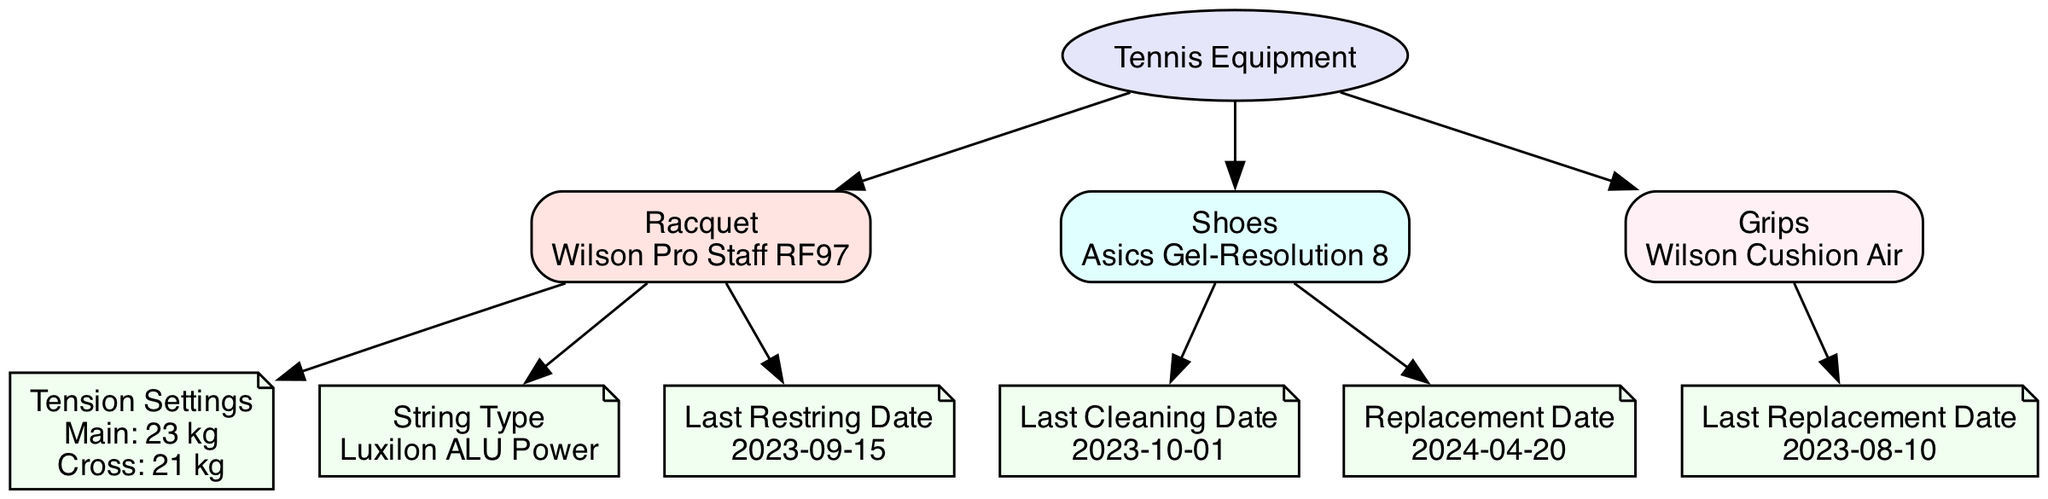What is the string type used for the racquet? To find the string type, locate the "Racquet" node, then look at the outgoing edge leading to the "String Type" node, which contains the value.
Answer: Luxilon ALU Power What is the last cleaning date for the shoes? To get the last cleaning date, find the "Shoes" node, then follow the edge to the "Last Cleaning Date" node, which provides the relevant date.
Answer: 2023-10-01 When was the last restring performed on the racquet? Check the "Racquet" node, then trace the edge to the "Last Restring Date" node to find out when the last restring took place.
Answer: 2023-09-15 What is the replacement date for the shoes? To answer this, find the "Shoes" node, and then follow the edge to the "Replacement Date" node to see when the shoes are scheduled for replacement.
Answer: 2024-04-20 How many types of equipment are listed in the diagram? Start at the "Equipment" node and count the unique child nodes connected to it: "Racquet," "Shoes," and "Grips."
Answer: 3 Which grip type is mentioned in the diagram? Locate the "Grips" node and check the text contained within it to find the specific grip type mentioned.
Answer: Wilson Cushion Air What are the main and cross tension settings for the racquet? Identify the "Racquet" node, then find the connected "Tension Settings" node, which contains both main and cross tension values.
Answer: Main: 23 kg, Cross: 21 kg Which piece of equipment has a last replacement date? Trace through the nodes to find that only the "Grips" node has a "Last Replacement Date" node, indicating it has this information associated with it.
Answer: Grips What color represents the shoes in the diagram? Look at the "Shoes" node and note its fill color, which is specified in the diagram's attributes.
Answer: E0FFFF 